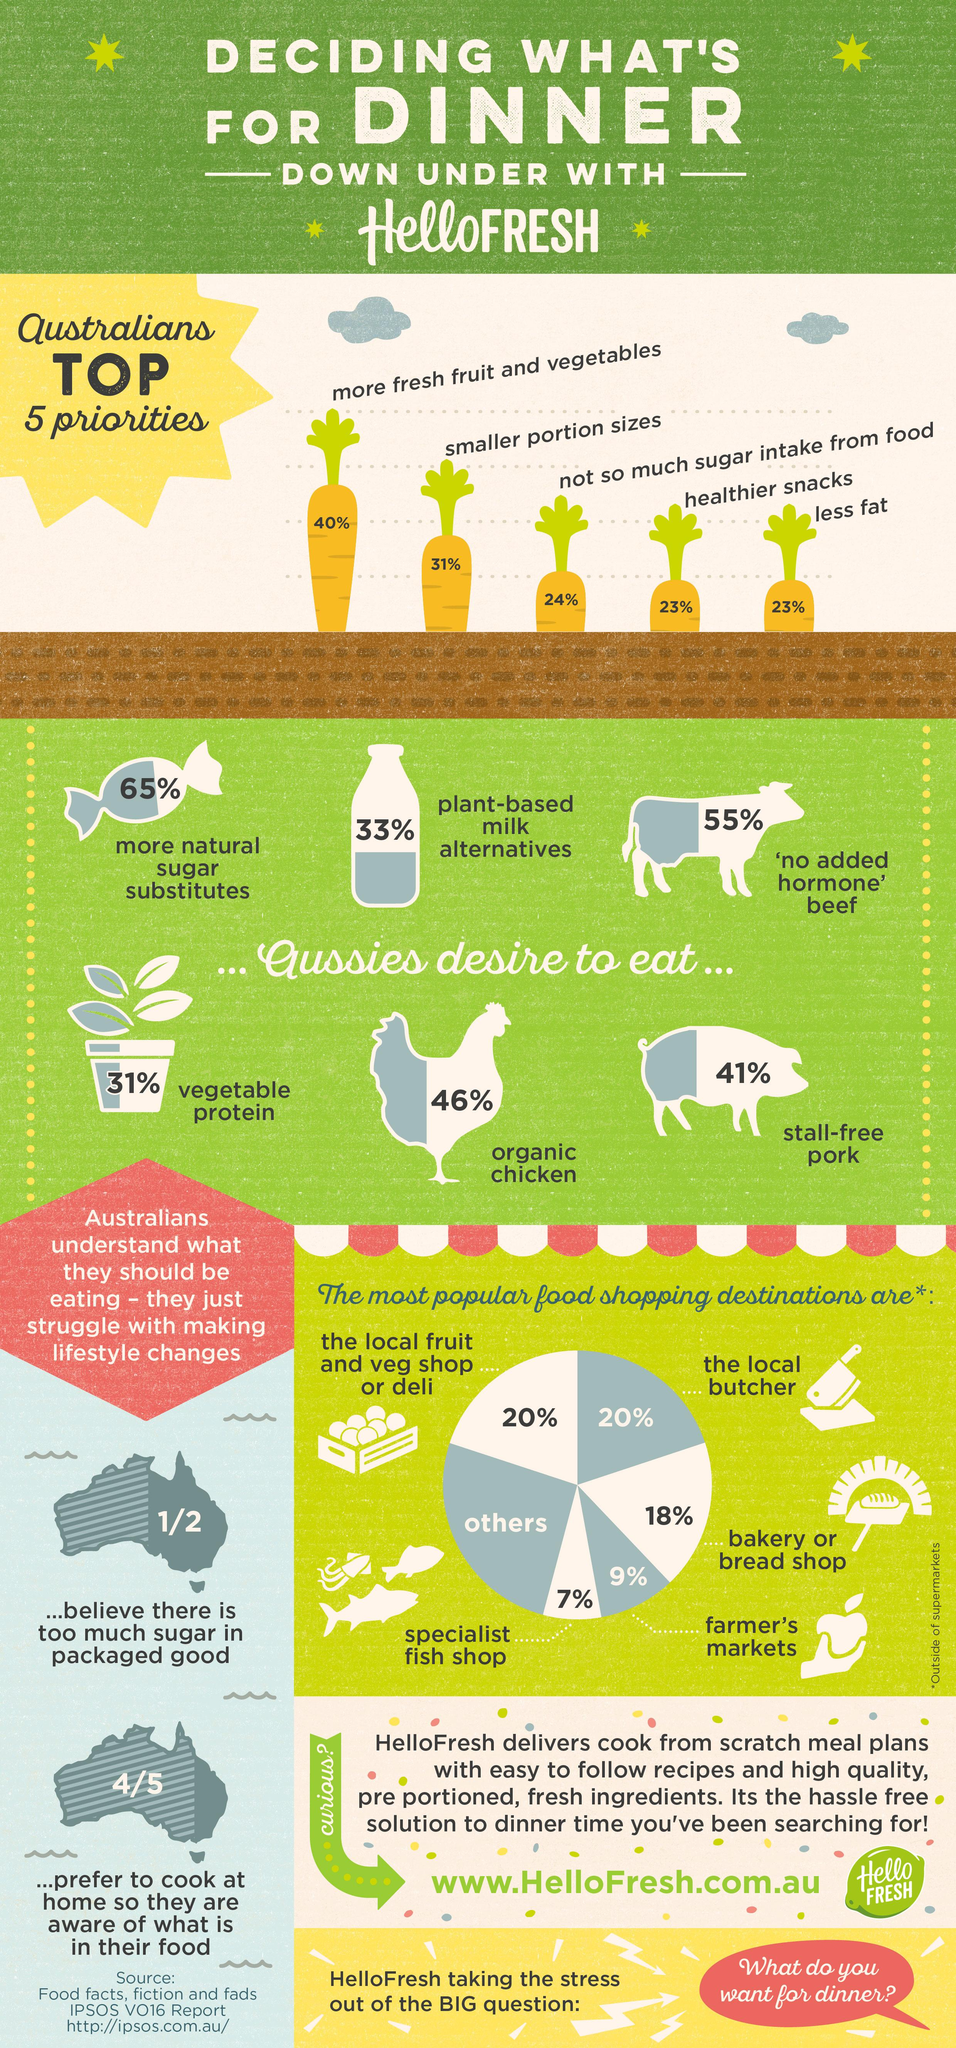Mention a couple of crucial points in this snapshot. According to a recent survey, 23% of Australians are actively trying to eat healthier snacks and consume less fat. A recent survey in Australia revealed that 46% of the population would like to eat chicken that is free from antibiotics. Additionally, 31% and 41% of the respondents also expressed a preference for antibiotic-free chicken. According to a recent survey, approximately 20% of Australians visit the local butcher or vegetable shop. Australians are known for their love of consuming animal products, particularly beef, chicken, and pork. 